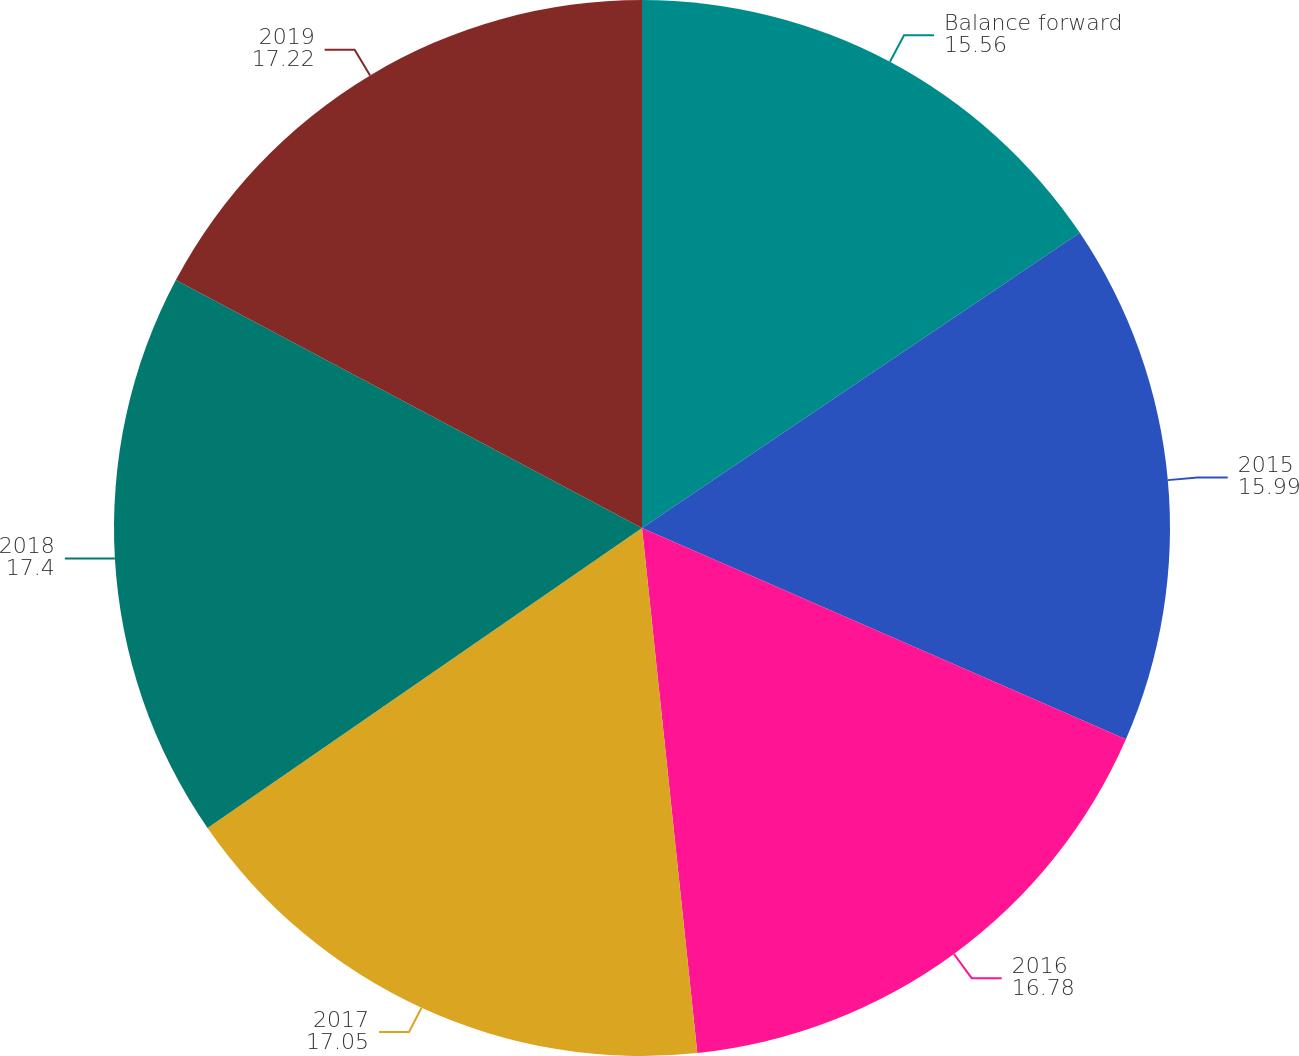Convert chart to OTSL. <chart><loc_0><loc_0><loc_500><loc_500><pie_chart><fcel>Balance forward<fcel>2015<fcel>2016<fcel>2017<fcel>2018<fcel>2019<nl><fcel>15.56%<fcel>15.99%<fcel>16.78%<fcel>17.05%<fcel>17.4%<fcel>17.22%<nl></chart> 